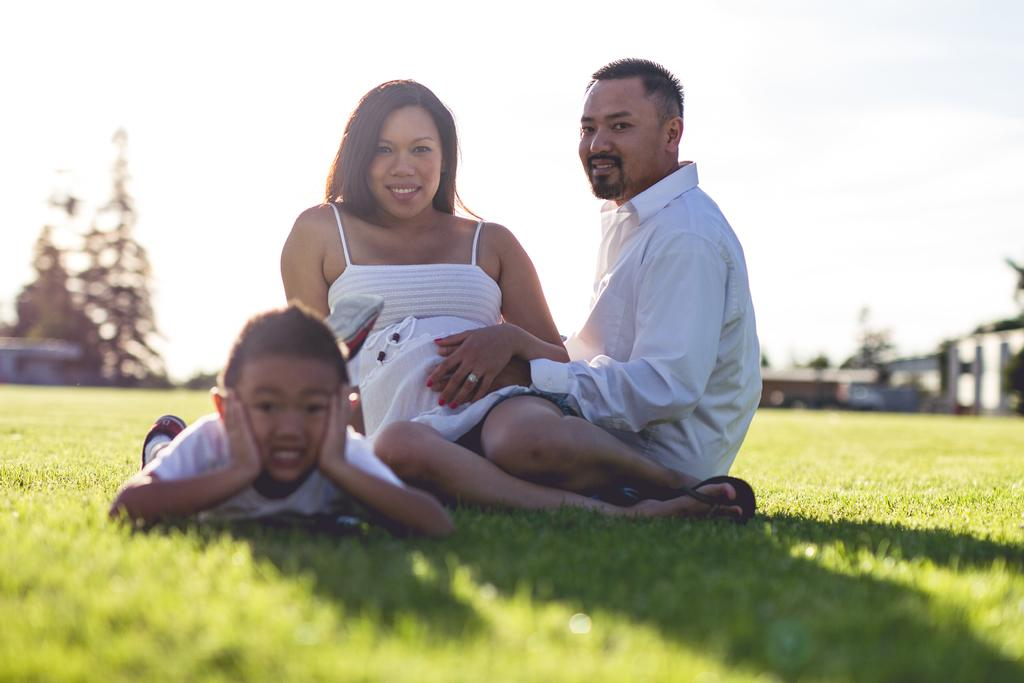How many people are sitting on the grass in the image? There are 2 people sitting on the grass in the image. What are the people wearing? The people are wearing white dresses. What is the position of the child in the image? The child is lying on the left side. What can be seen in the background of the image? There are trees and buildings in the background. What type of pan is being used by the people in the image? There is no pan present in the image; the people are sitting on the grass and wearing white dresses. 